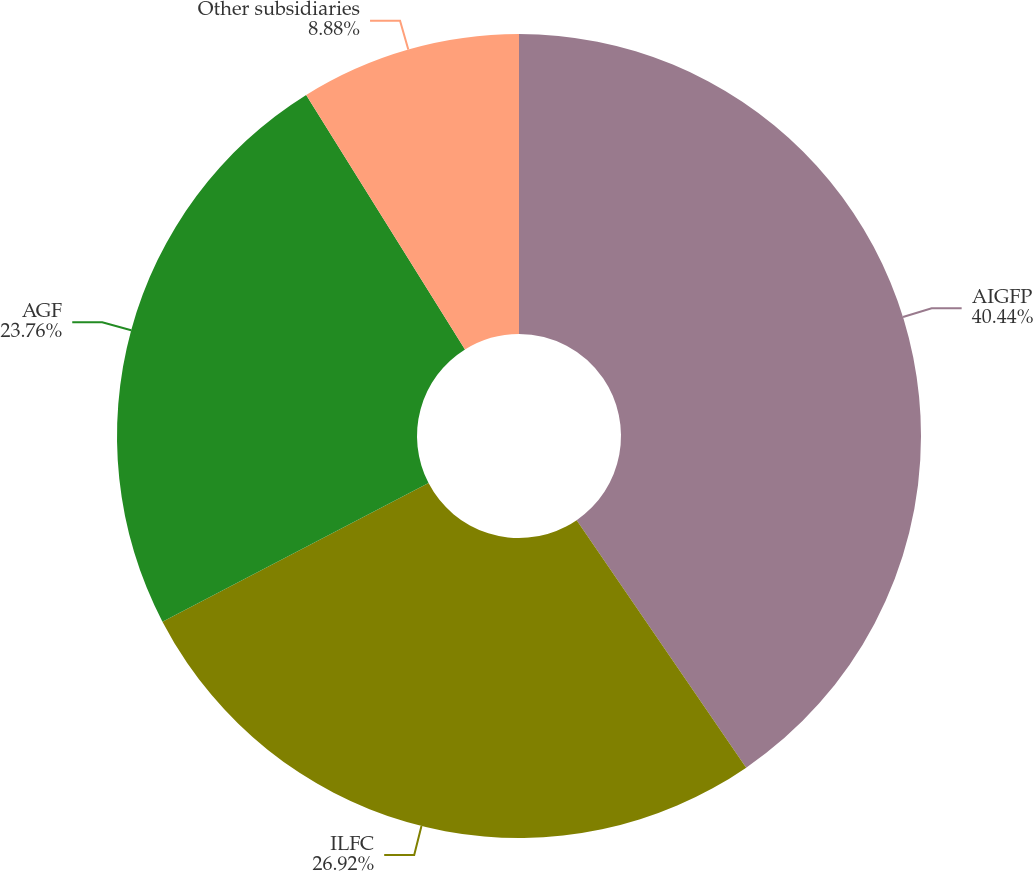Convert chart to OTSL. <chart><loc_0><loc_0><loc_500><loc_500><pie_chart><fcel>AIGFP<fcel>ILFC<fcel>AGF<fcel>Other subsidiaries<nl><fcel>40.44%<fcel>26.92%<fcel>23.76%<fcel>8.88%<nl></chart> 